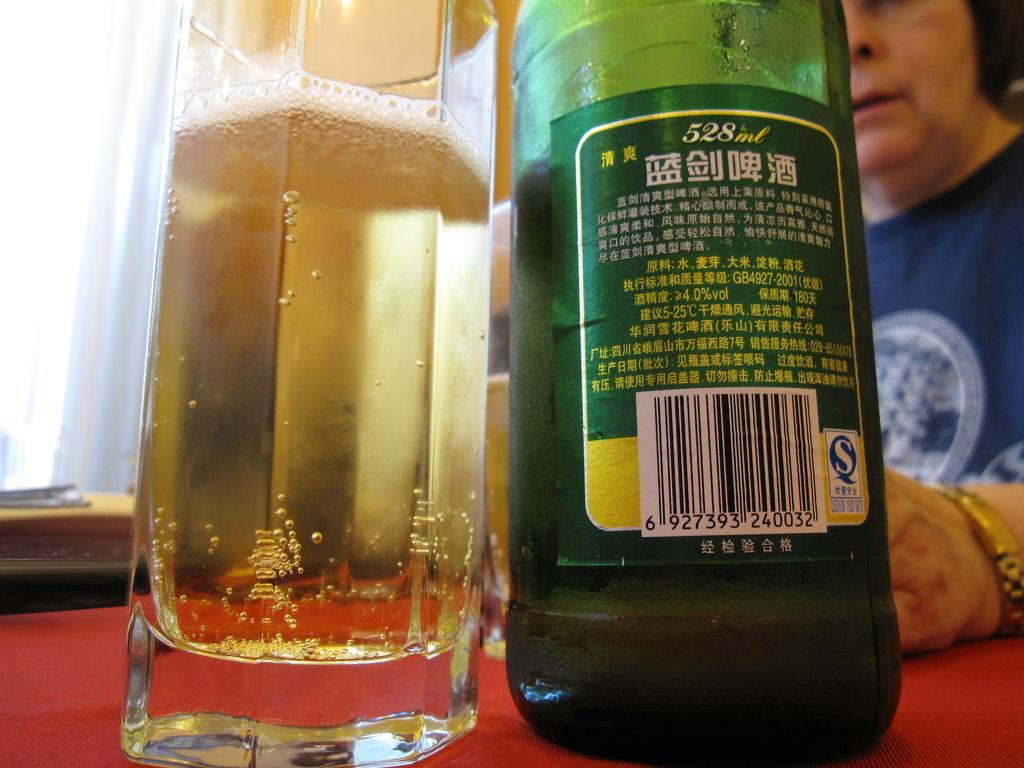<image>
Give a short and clear explanation of the subsequent image. Bottle of alcohol at 528ml next to a glass cup. 